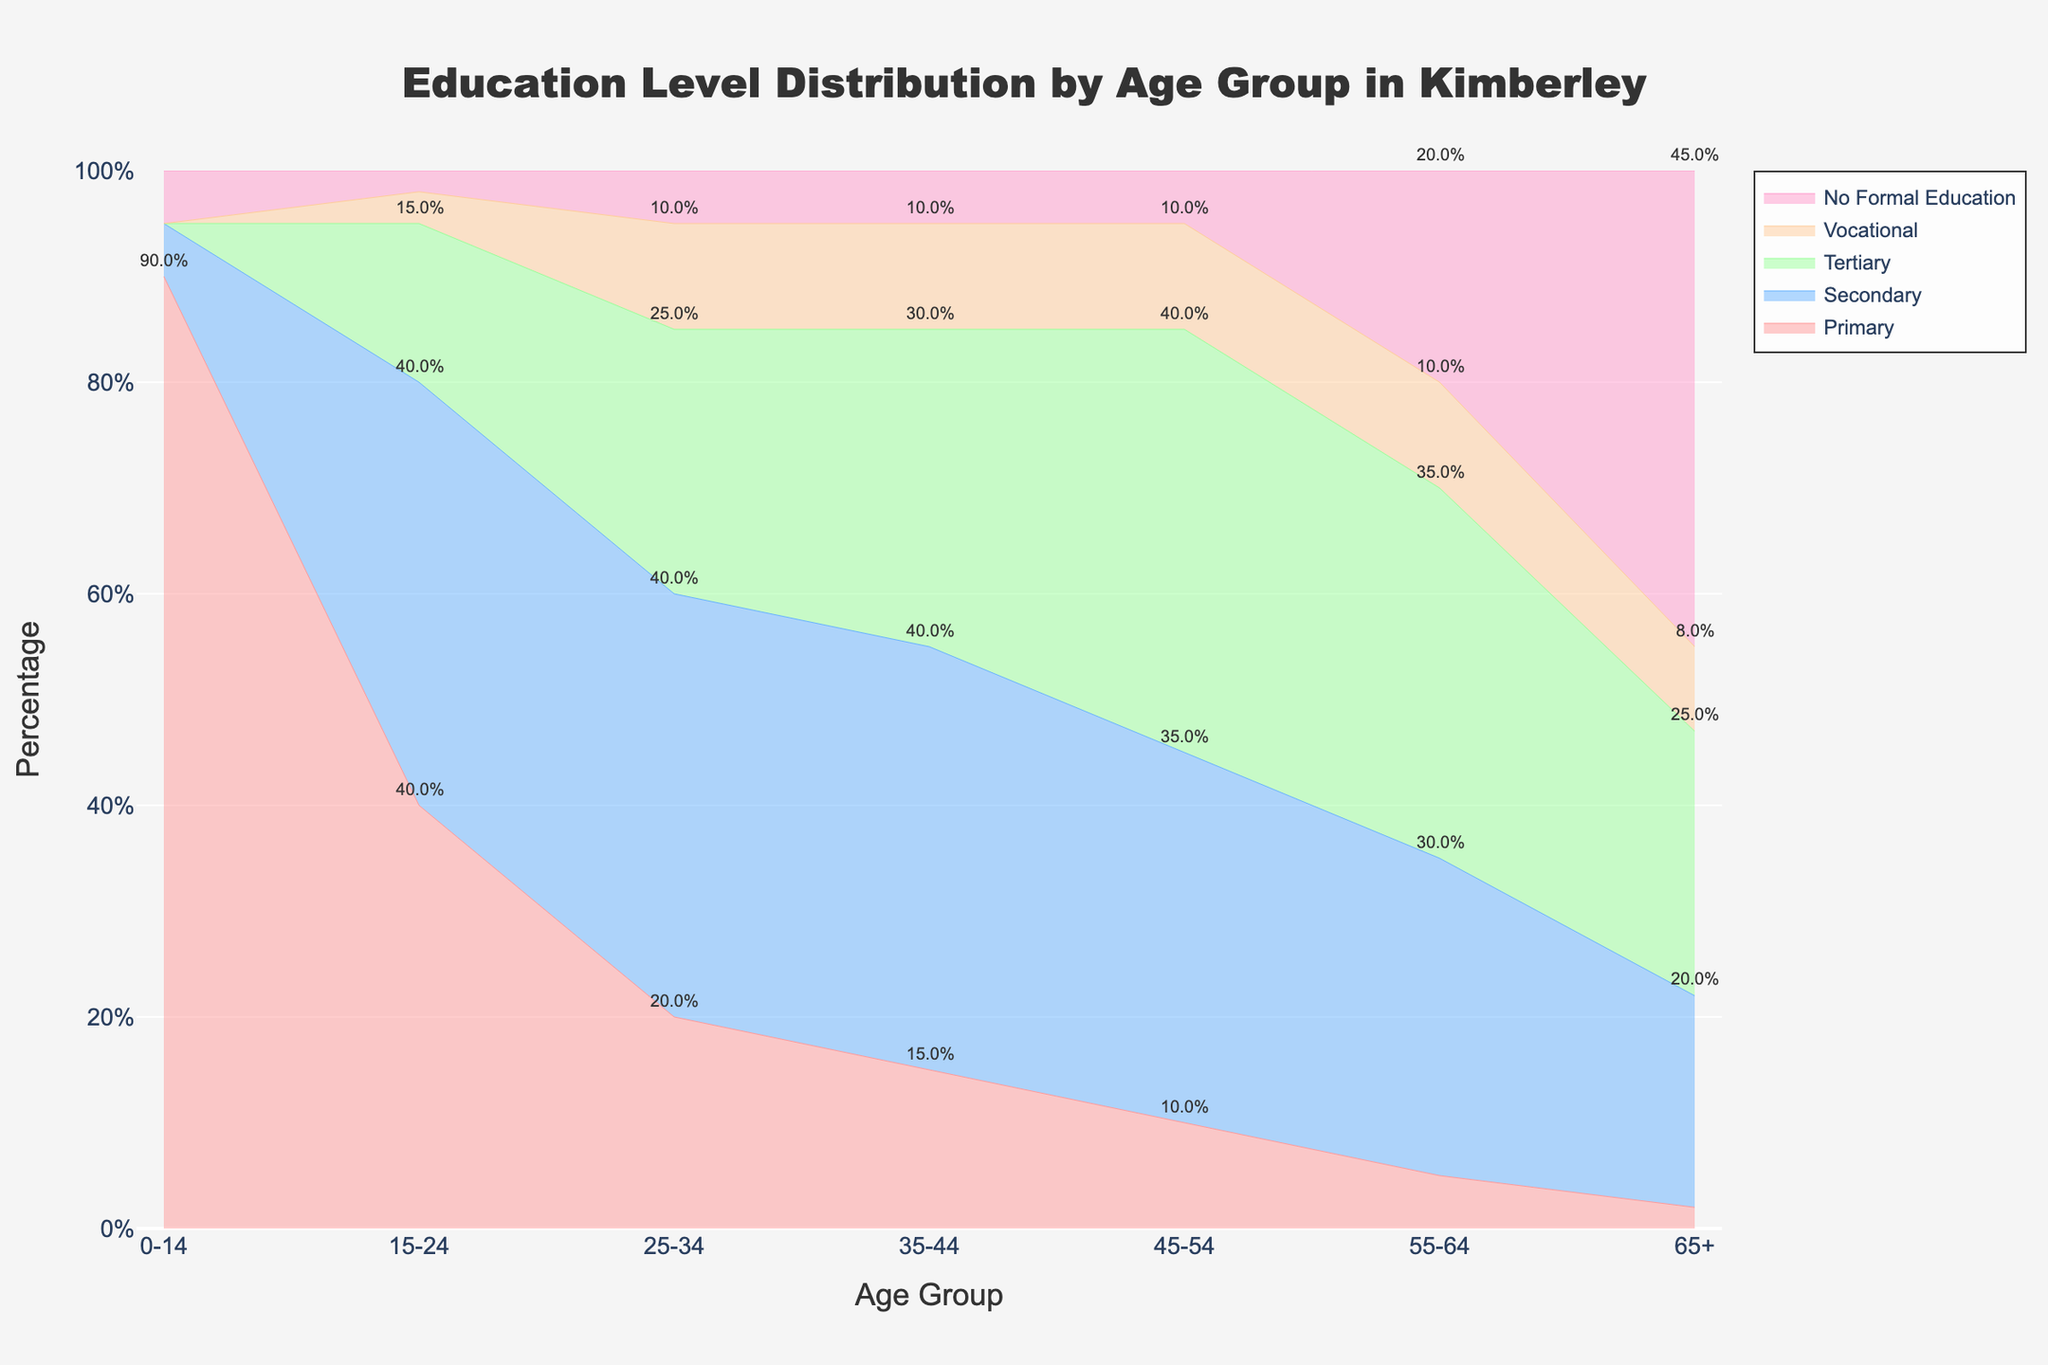What is the title of the chart? The title of the chart is a text element situated at the top, which reads "Education Level Distribution by Age Group in Kimberley".
Answer: Education Level Distribution by Age Group in Kimberley Which age group has the highest percentage of individuals with tertiary education? To find the highest percentage of individuals with tertiary education, check the category "Tertiary" across all age groups. The age group 45-54 has the highest percentage of 40%.
Answer: 45-54 In which age group does the "No Formal Education" category have the largest portion? Examine the "No Formal Education" section within each age group to find the one with the largest portion. The age group 65+ has the largest portion with 45%.
Answer: 65+ What is the sum of the percentages of primary and secondary education in the 0-14 age group? Look at the Primary and Secondary sections for the 0-14 age group. Add their percentages: 90% (Primary) + 5% (Secondary) = 95%.
Answer: 95% Which age group has an equal percentage of secondary and tertiary education? Compare the percentages of secondary and tertiary education across all age groups. The age group 35-44 has equal percentages of 40% for both secondary and tertiary education.
Answer: 35-44 How does the percentage of vocational education in the 25-34 age group compare to the 35-44 age group? To compare, look at the Vocational section for both age groups: 25-34 (10%) and 35-44 (10%). Both age groups have the same percentage of vocational education.
Answer: Same What percentage of the 55-64 age group has no formal education? Identify the "No Formal Education" section for the 55-64 age group, which is marked at 20%.
Answer: 20% Is there any age group where no one has tertiary education? Check the "Tertiary" section for each age group to see if any of them have a 0%. The 0-14 age group has 0% in tertiary education.
Answer: Yes, 0-14 Across all age groups, which education level shows a consistent increase in percentage as age decreases? Evaluate all education levels and their trends across the age groups. The percentage of individuals with tertiary education consistently increases as the age decreases from 65+ down to the 0-14 age group.
Answer: Tertiary 